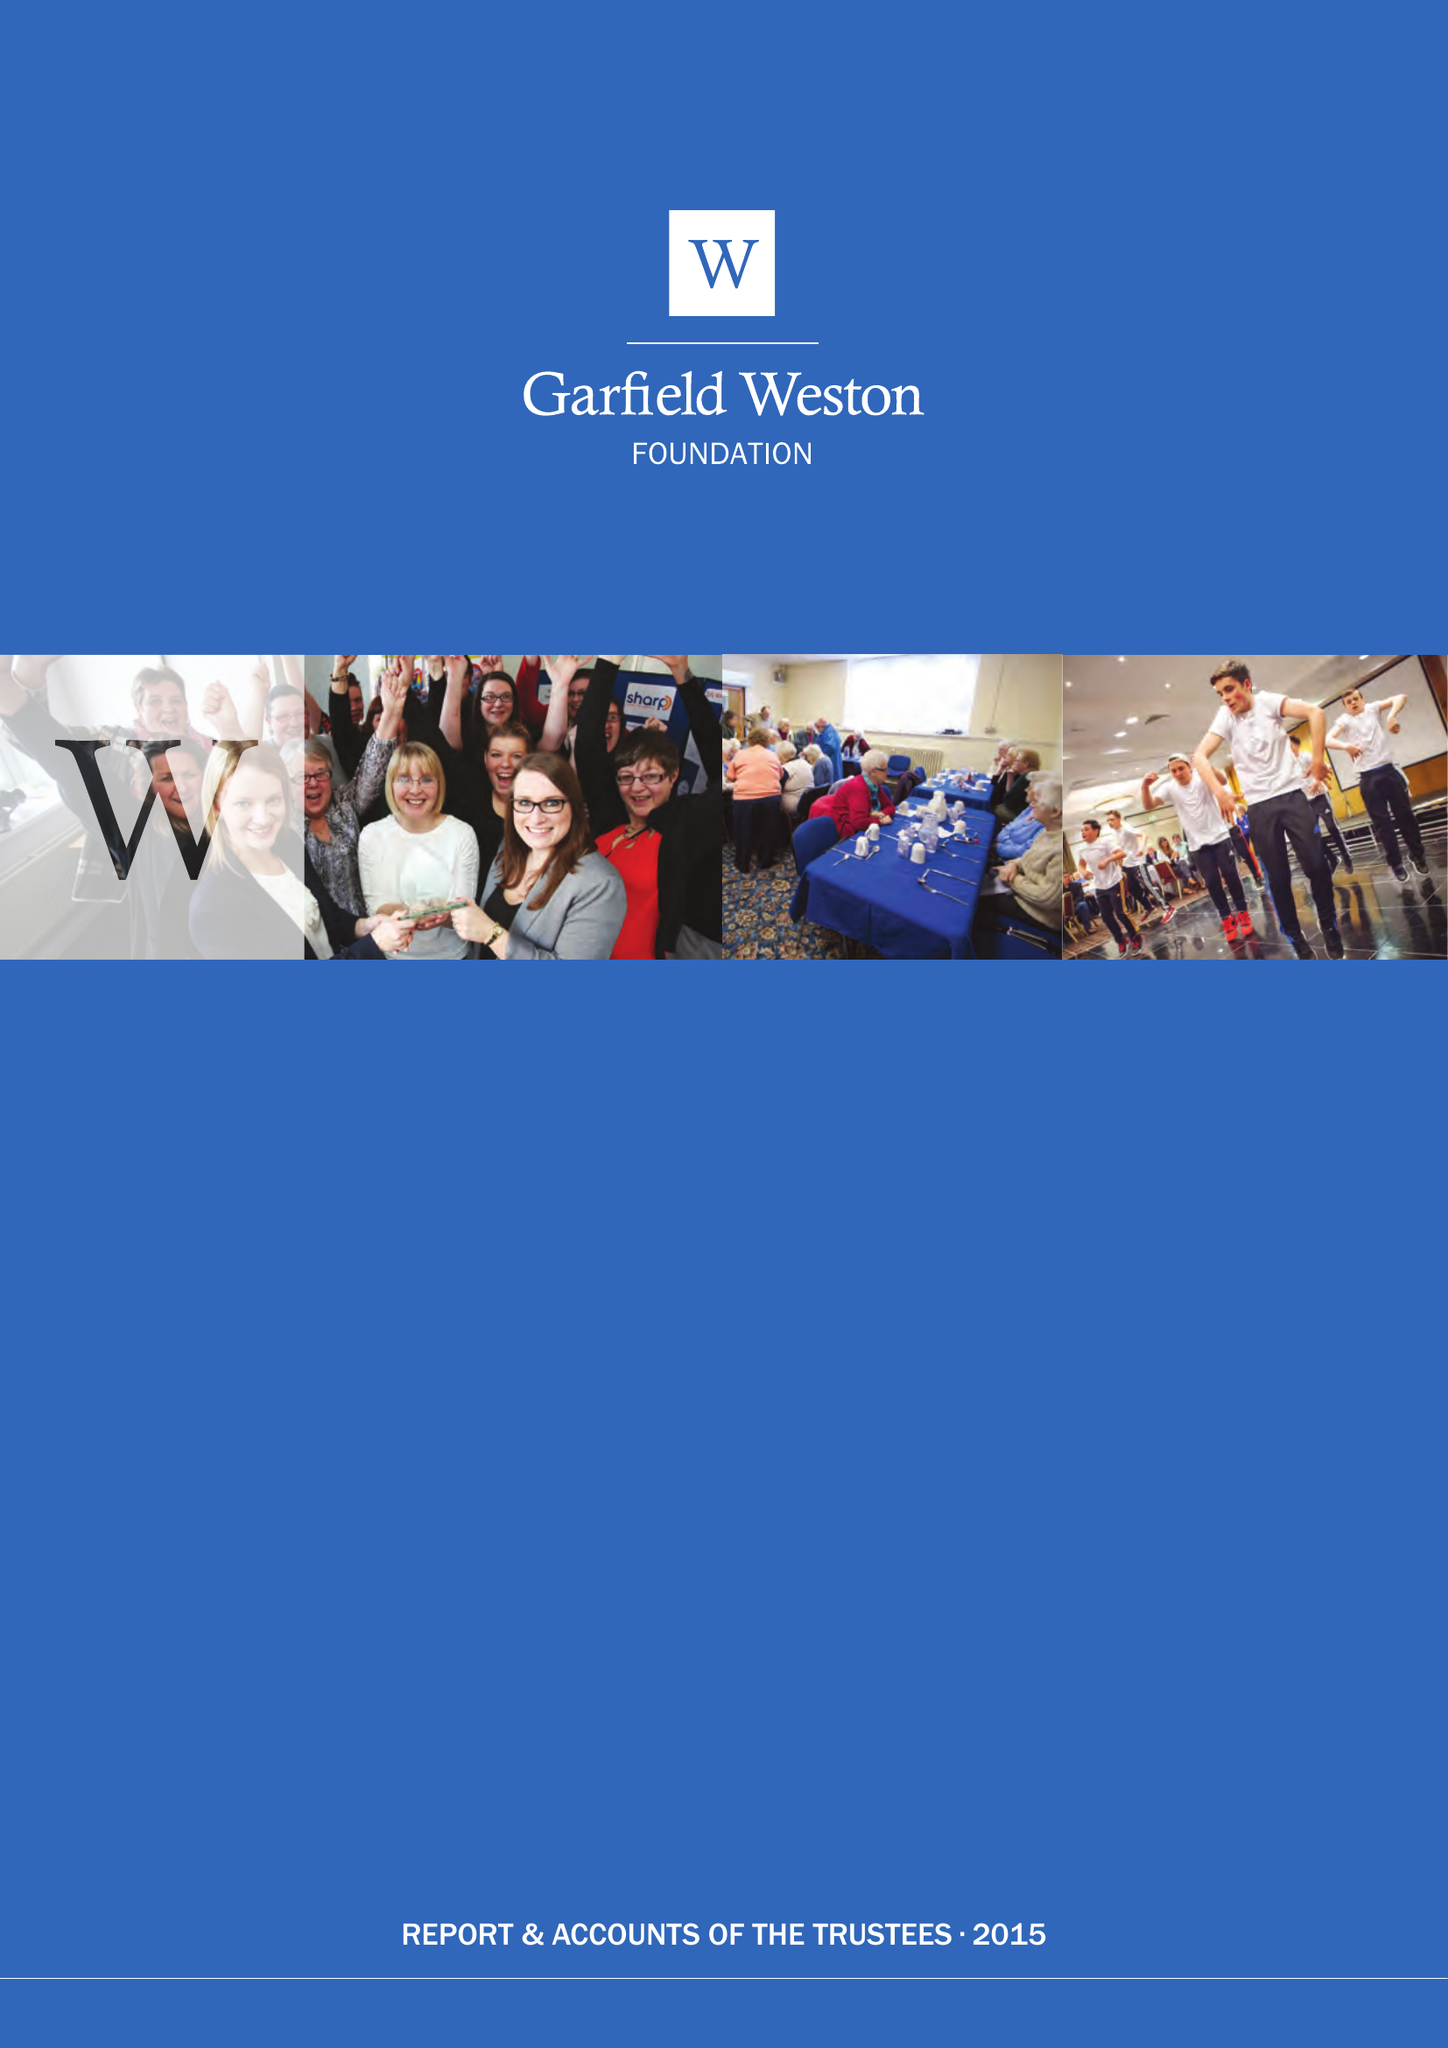What is the value for the spending_annually_in_british_pounds?
Answer the question using a single word or phrase. 59049000.00 